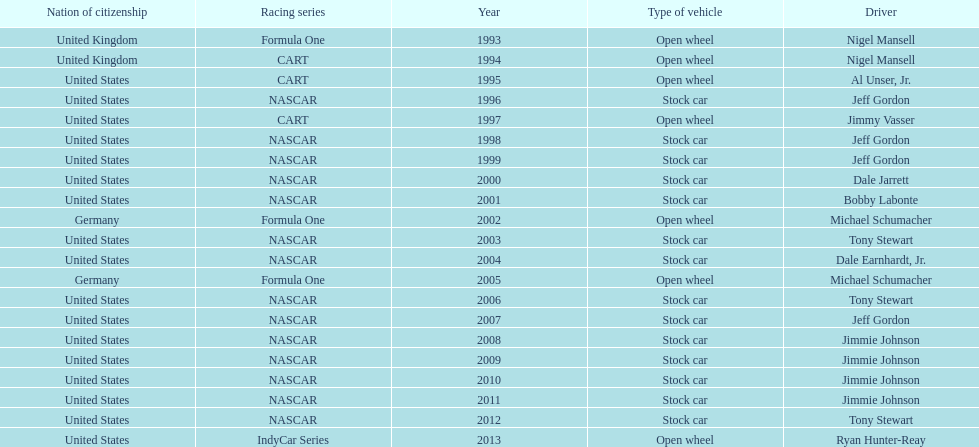Which driver won espy awards 11 years apart from each other? Jeff Gordon. 